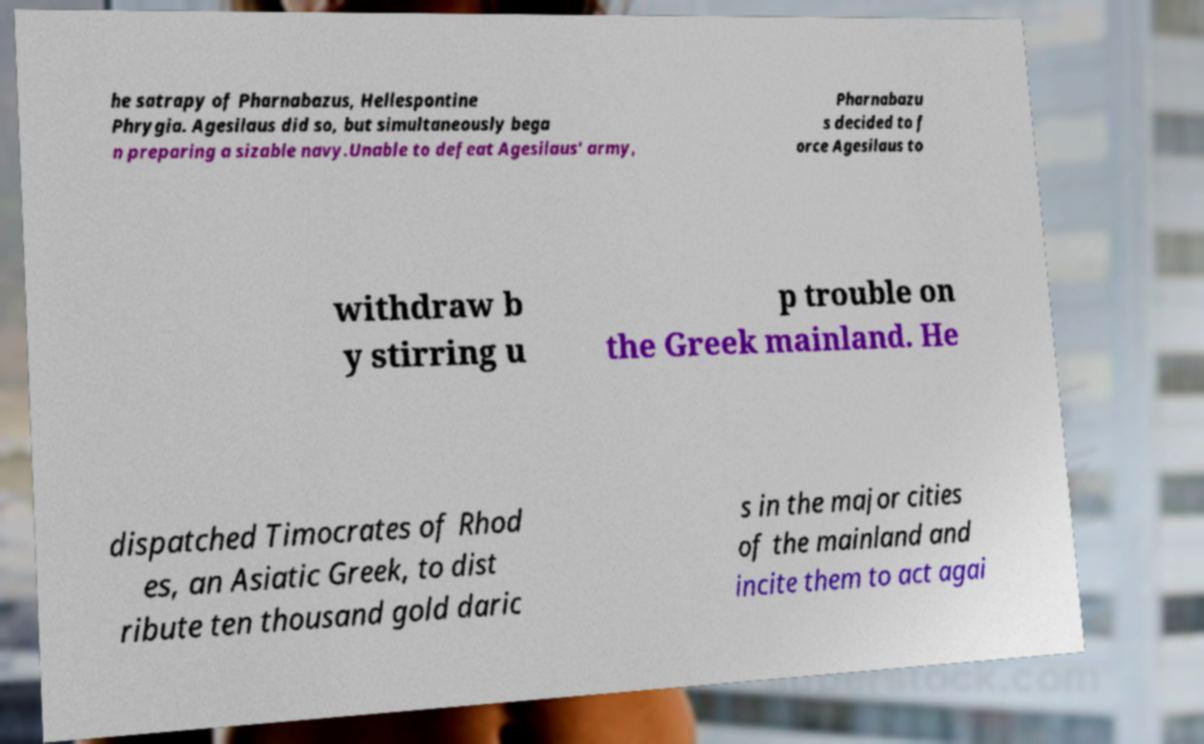Could you assist in decoding the text presented in this image and type it out clearly? he satrapy of Pharnabazus, Hellespontine Phrygia. Agesilaus did so, but simultaneously bega n preparing a sizable navy.Unable to defeat Agesilaus' army, Pharnabazu s decided to f orce Agesilaus to withdraw b y stirring u p trouble on the Greek mainland. He dispatched Timocrates of Rhod es, an Asiatic Greek, to dist ribute ten thousand gold daric s in the major cities of the mainland and incite them to act agai 